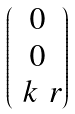Convert formula to latex. <formula><loc_0><loc_0><loc_500><loc_500>\begin{pmatrix} 0 \\ 0 \\ \ k \ r \end{pmatrix}</formula> 